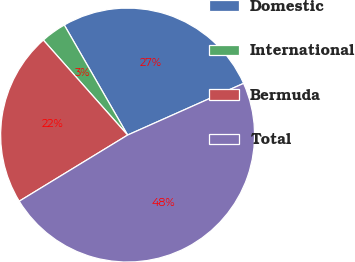Convert chart to OTSL. <chart><loc_0><loc_0><loc_500><loc_500><pie_chart><fcel>Domestic<fcel>International<fcel>Bermuda<fcel>Total<nl><fcel>26.64%<fcel>3.24%<fcel>22.17%<fcel>47.95%<nl></chart> 